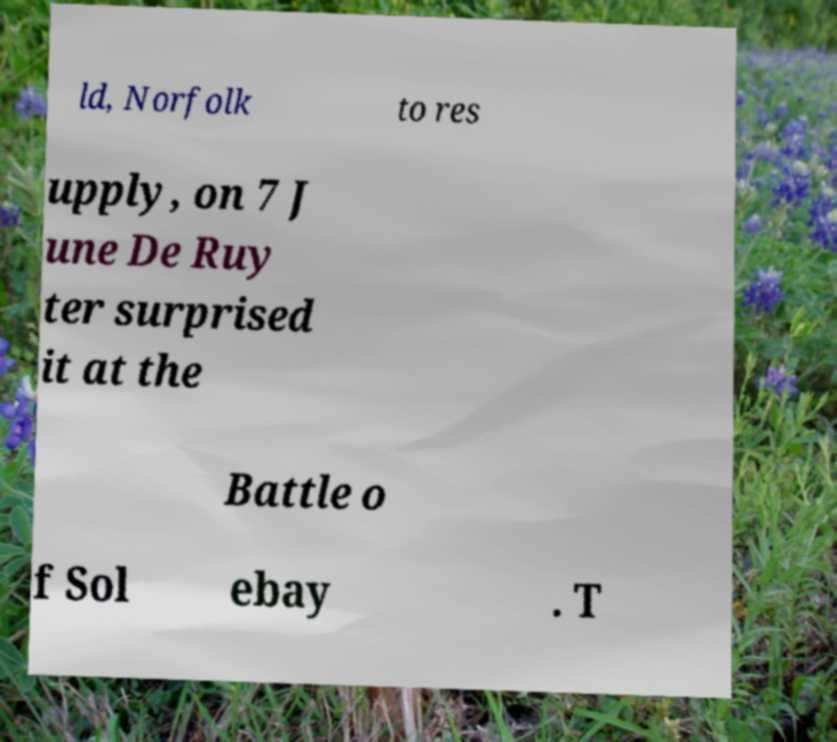Can you read and provide the text displayed in the image?This photo seems to have some interesting text. Can you extract and type it out for me? ld, Norfolk to res upply, on 7 J une De Ruy ter surprised it at the Battle o f Sol ebay . T 